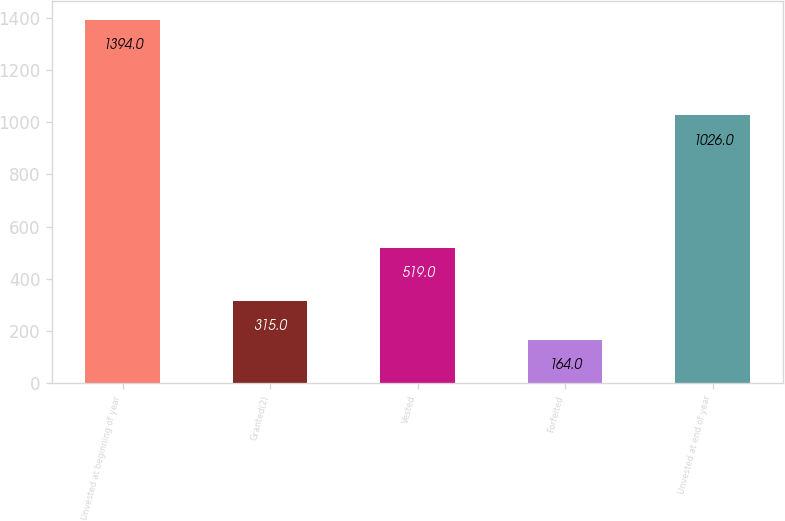<chart> <loc_0><loc_0><loc_500><loc_500><bar_chart><fcel>Unvested at beginning of year<fcel>Granted(2)<fcel>Vested<fcel>Forfeited<fcel>Unvested at end of year<nl><fcel>1394<fcel>315<fcel>519<fcel>164<fcel>1026<nl></chart> 